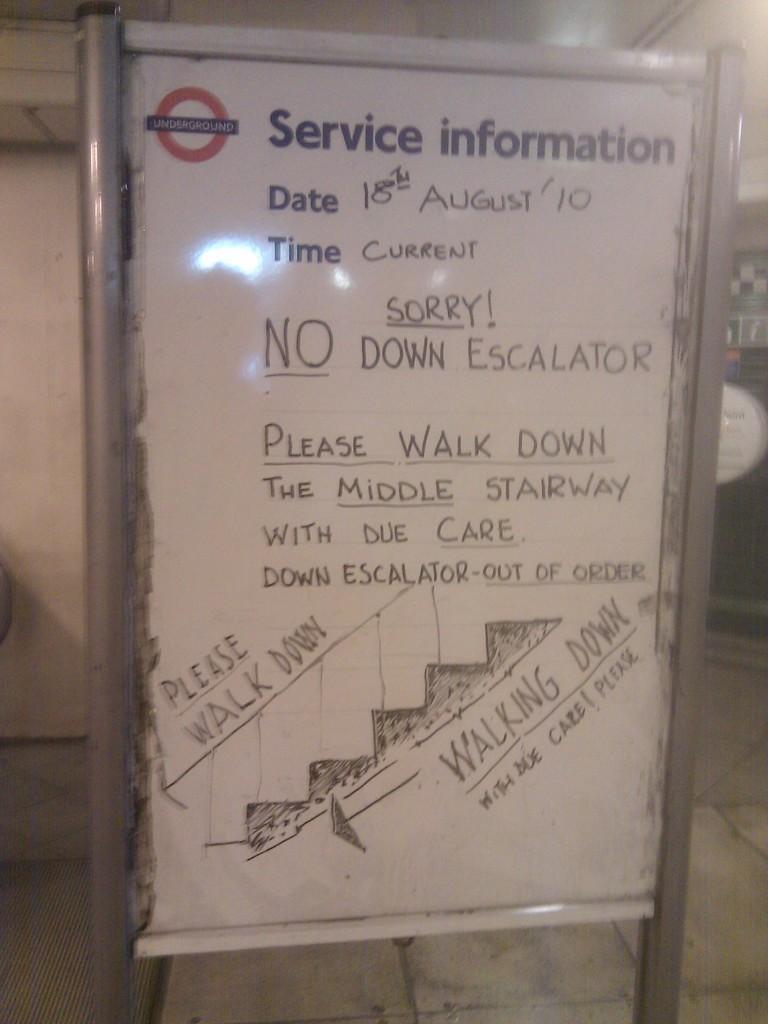In one or two sentences, can you explain what this image depicts? In this picture I can see in the middle there is a board with text written on it. 